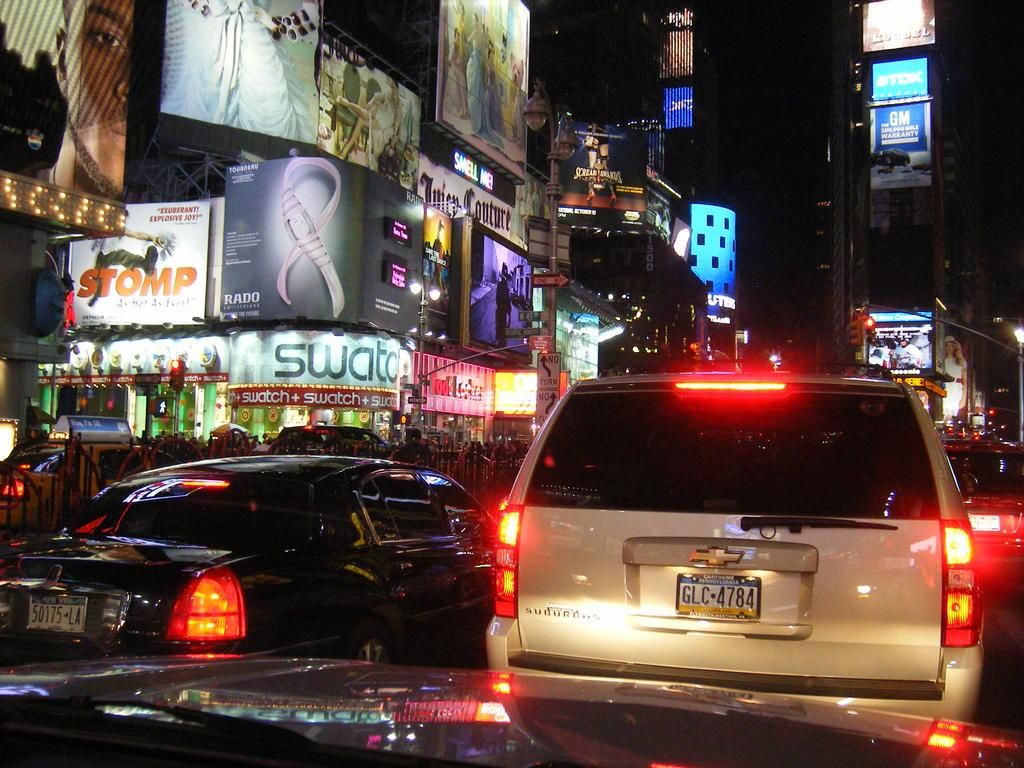<image>
Summarize the visual content of the image. The sign on the left has the word swatch on it. 